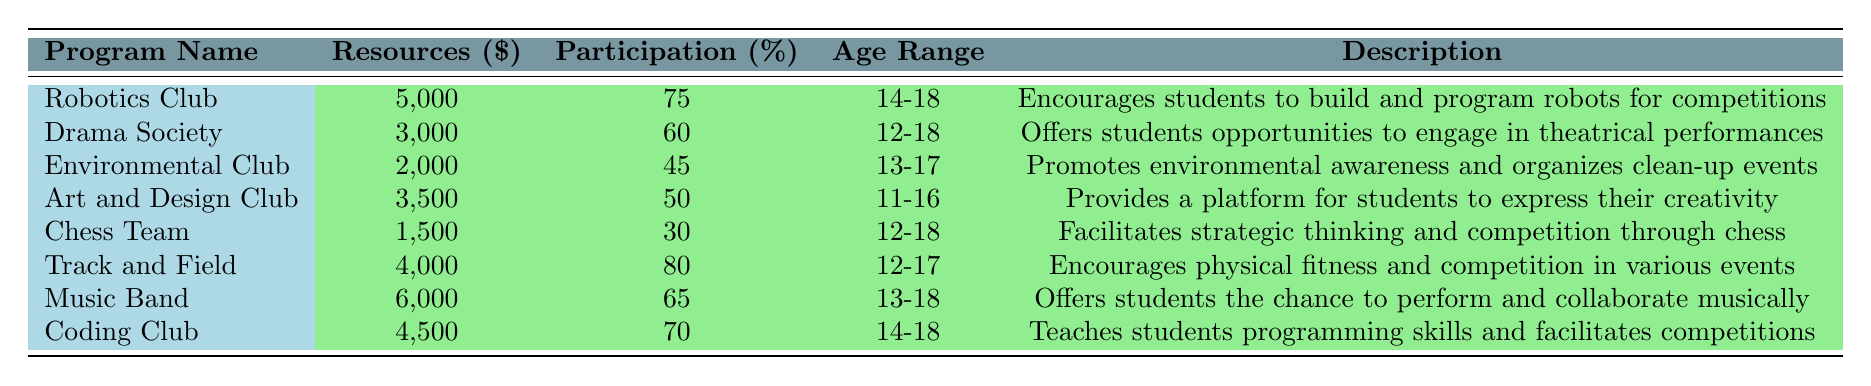What is the allocated resource for the Music Band? The table shows that the allocated resources for the Music Band are $6,000.
Answer: $6,000 Which extracurricular program has the highest participation rate? Looking at the participation rates in the table, Track and Field has the highest rate at 80%.
Answer: 80% How many programs have a participation rate of 60% or higher? The programs with rates of 60% or higher are Robotics Club, Drama Society, Track and Field, Music Band, and Coding Club. There are 5 in total.
Answer: 5 What is the average allocated resource for all the programs? To find the average, sum the allocated resources: 5000 + 3000 + 2000 + 3500 + 1500 + 4000 + 6000 + 4500 = 30,500. There are 8 programs, so the average is 30,500 / 8 = 3,812.5.
Answer: 3,812.5 Is there any program for students aged 11 to 16? Yes, the Art and Design Club has an age range of 11-16 years old.
Answer: Yes Which program has the least allocated resources and what is its participation rate? The Chess Team has the least allocated resources at $1,500, and its participation rate is 30%.
Answer: $1,500, 30% If we were to remove the lowest participation rate program, what would the new average participation rate be? The lowest is the Chess Team with 30%. Removing it gives scores of 75, 60, 45, 50, 80, 65, and 70; averaging these: (75 + 60 + 45 + 50 + 80 + 65 + 70) / 7 = 65.
Answer: 65 Which two programs together have the closest budget to $10,000? The combinations are really close when adding Robotics Club ($5,000) and Music Band ($6,000) for a total of $11,000, making it the closest.
Answer: Robotics Club and Music Band Are there any environmental clubs with a higher participation rate than the Environmental Club? No, the Environmental Club has a participation rate of 45%, and the only programs with higher rates are the Track and Field (80%), the Robotics Club (75%), Music Band (65%), and Coding Club (70%).
Answer: Yes, there are programs with higher rates 